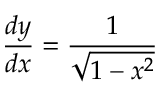<formula> <loc_0><loc_0><loc_500><loc_500>{ \frac { d y } { d x } } = { \frac { 1 } { \sqrt { 1 - x ^ { 2 } } } }</formula> 